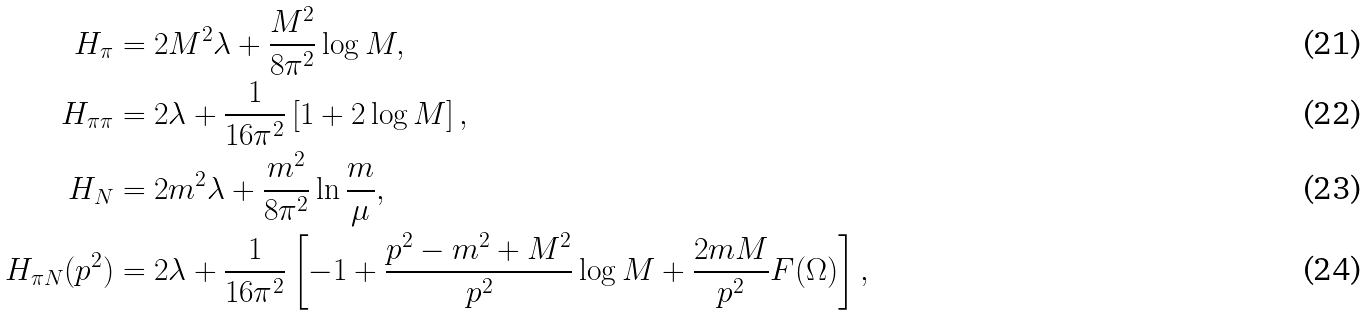<formula> <loc_0><loc_0><loc_500><loc_500>H _ { \pi } & = 2 M ^ { 2 } \lambda + \frac { M ^ { 2 } } { 8 \pi ^ { 2 } } \log M , \\ H _ { \pi \pi } & = 2 \lambda + \frac { 1 } { 1 6 \pi ^ { 2 } } \left [ 1 + 2 \log M \right ] , \\ H _ { N } & = 2 m ^ { 2 } \lambda + \frac { m ^ { 2 } } { 8 \pi ^ { 2 } } \ln \frac { m } { \mu } , \\ H _ { \pi N } ( p ^ { 2 } ) & = 2 \lambda + \frac { 1 } { 1 6 \pi ^ { 2 } } \left [ - 1 + \frac { p ^ { 2 } - m ^ { 2 } + M ^ { 2 } } { p ^ { 2 } } \log M + \frac { 2 m M } { p ^ { 2 } } F ( \Omega ) \right ] ,</formula> 